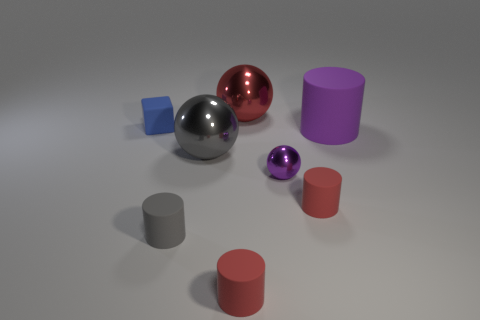Subtract all purple rubber cylinders. How many cylinders are left? 3 Add 1 balls. How many objects exist? 9 Subtract all gray cylinders. How many cylinders are left? 3 Subtract all blocks. How many objects are left? 7 Subtract all red cubes. How many red cylinders are left? 2 Subtract 3 cylinders. How many cylinders are left? 1 Add 2 tiny red objects. How many tiny red objects exist? 4 Subtract 0 cyan cubes. How many objects are left? 8 Subtract all yellow cylinders. Subtract all red cubes. How many cylinders are left? 4 Subtract all big purple objects. Subtract all small green matte cylinders. How many objects are left? 7 